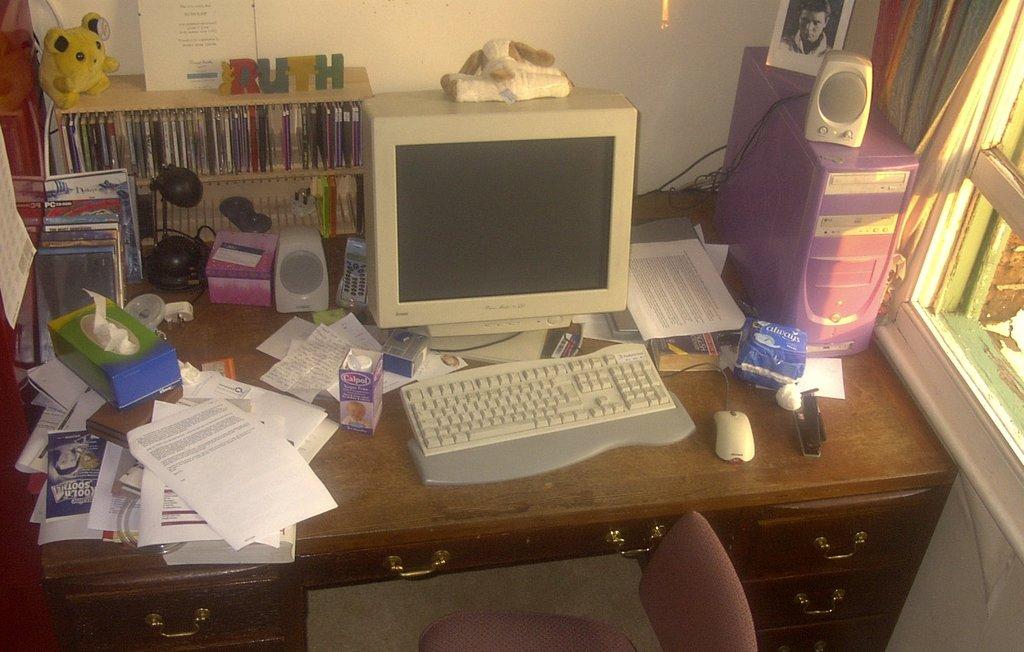What name is on the cd shelf?
Ensure brevity in your answer.  Ruth. What blue product is next to the computer tower?
Provide a succinct answer. Always. 